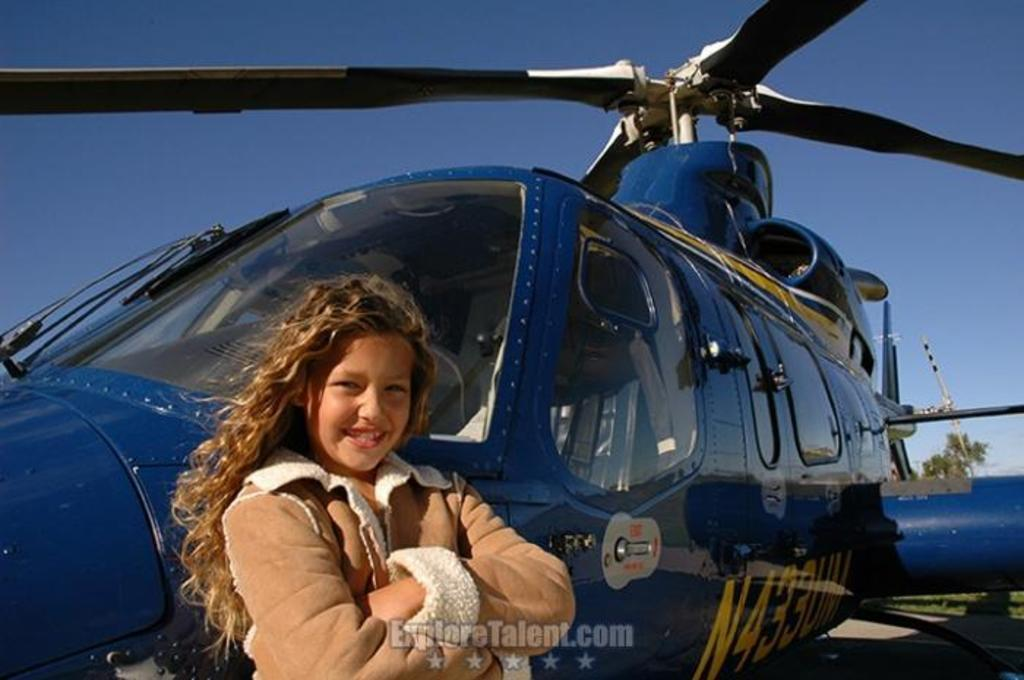<image>
Give a short and clear explanation of the subsequent image. A young girl poses in front of a blue helicopter with the call number N433UM. 